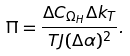<formula> <loc_0><loc_0><loc_500><loc_500>\Pi = \frac { \Delta C _ { \Omega _ { H } } \Delta k _ { T } } { T J ( \Delta \alpha ) ^ { 2 } } .</formula> 